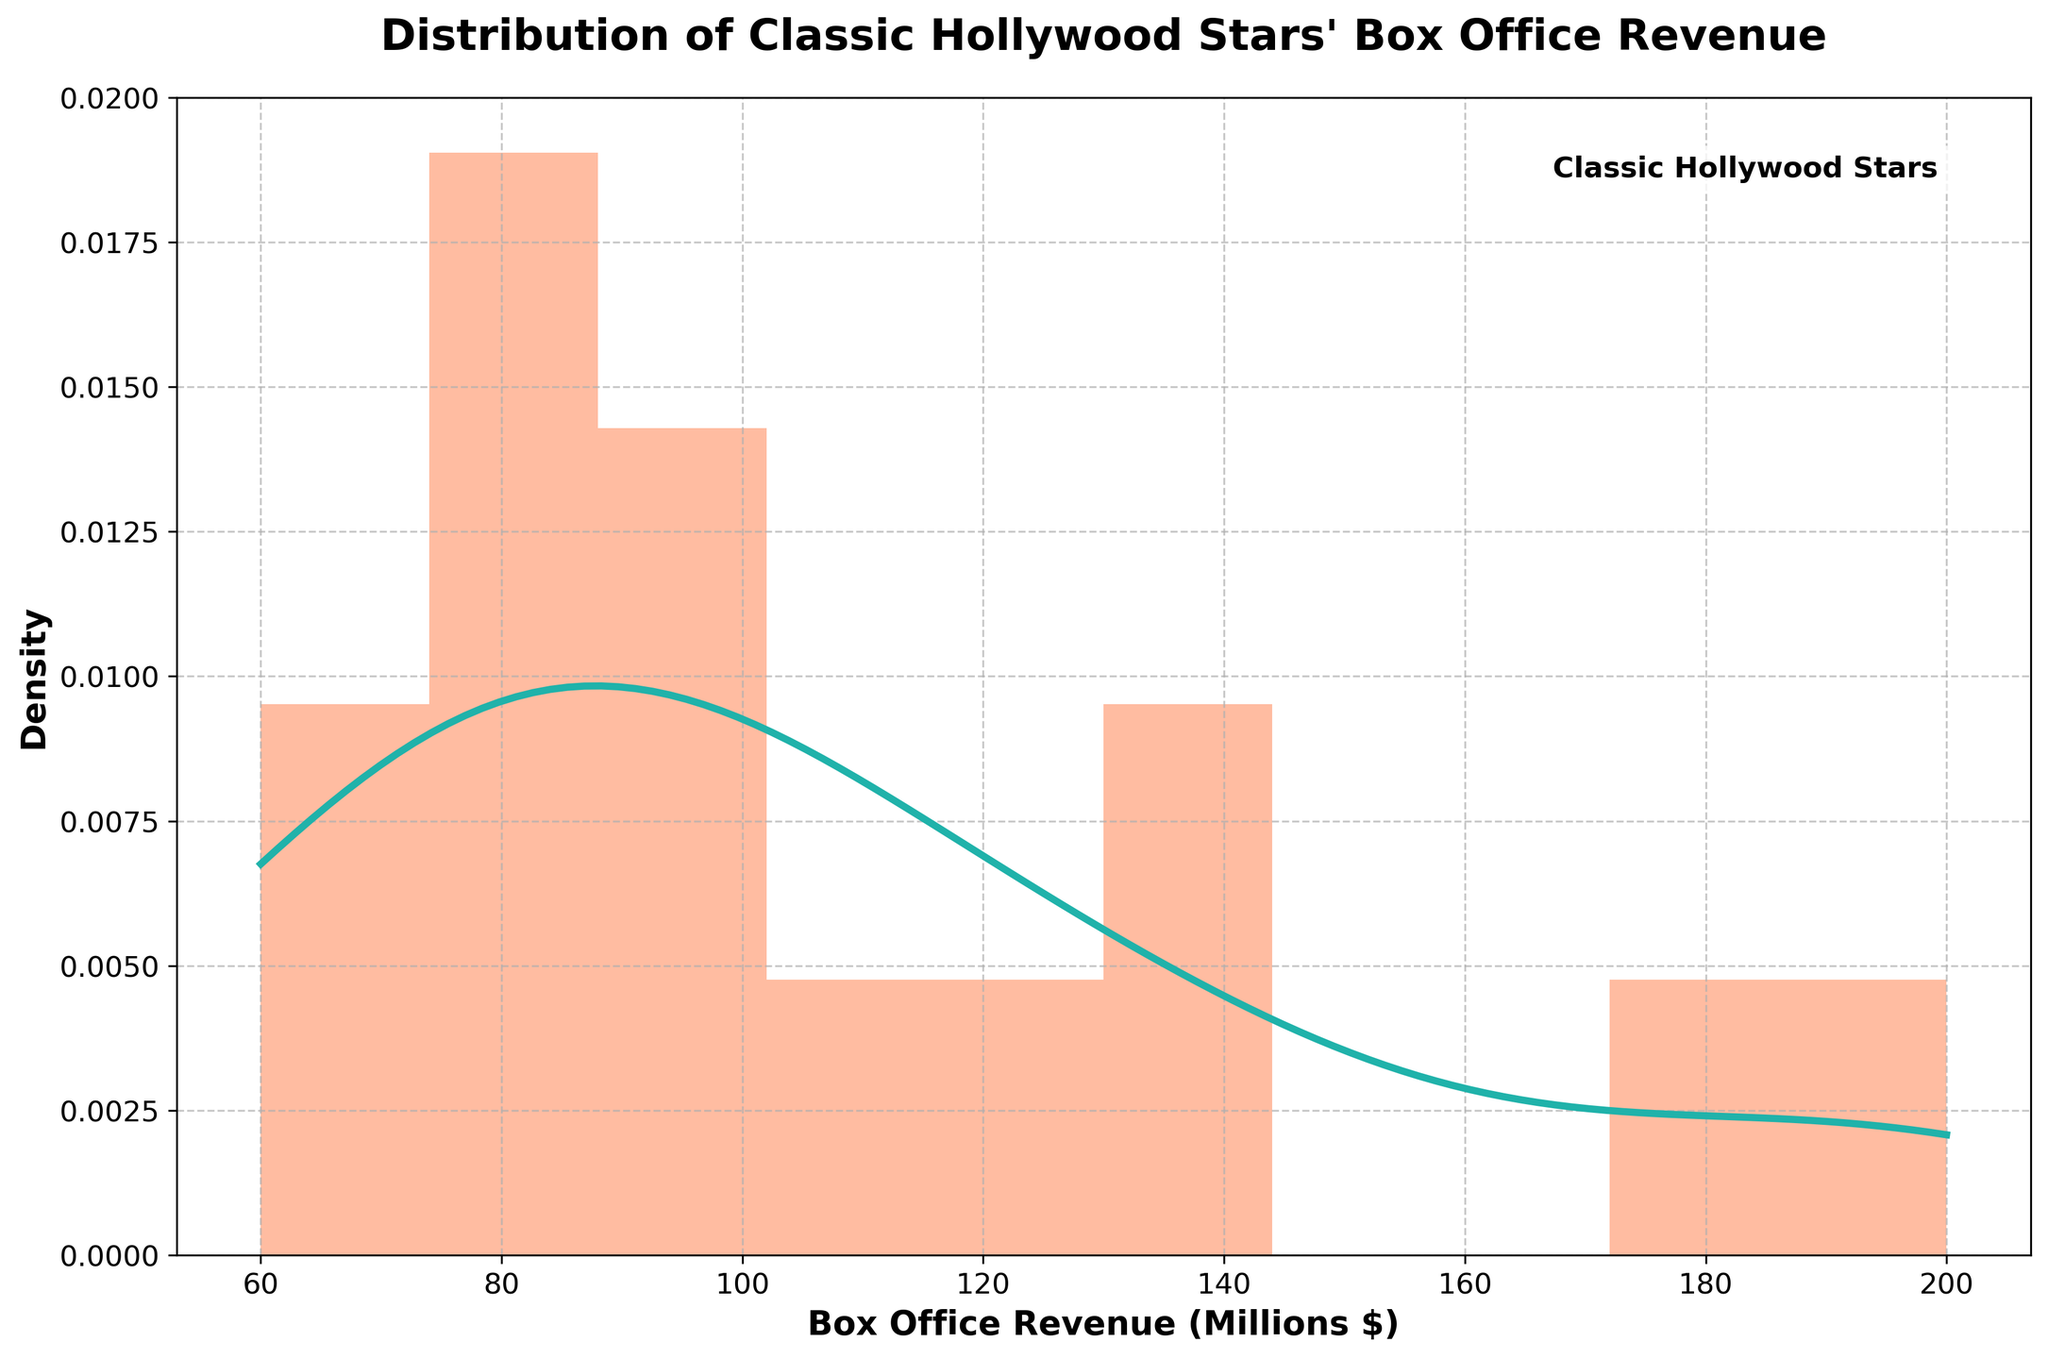What's the title of the figure? The title is typically located at the top of the figure. It gives a summary of what the figure is about, which in this case is 'Distribution of Classic Hollywood Stars' Box Office Revenue'.
Answer: Distribution of Classic Hollywood Stars' Box Office Revenue Which axis shows Box Office Revenue? By looking at the figure, we see that axes are labeled. The x-axis is labeled 'Box Office Revenue (Millions $)', indicating it shows the Box Office Revenue.
Answer: x-axis What does the y-axis represent? The y-axis is labeled 'Density', suggesting that the vertical position of points corresponds to the density estimate of the stars' box office revenue.
Answer: Density How many bars are in the histogram? A histogram typically contains several bars, each representing a range of values. By counting these bars, we can see there are 10 bars in the histogram.
Answer: 10 What can you infer about the range of revenue from the histogram? By examining the x-axis and the coverage of the bars, it is possible to deduce that the revenue ranges from 60 million dollars to 200 million dollars.
Answer: 60 million to 200 million dollars Which color represents the KDE curve? By observing the plot, we can see that the KDE curve is drawn in a different color from the bars of the histogram. The color of the KDE curve is '#20B2AA' or a shade of teal.
Answer: Teal What is the shape of the distribution of box office revenue? Examining the KDE curve and the histogram bars, we can notice that the revenue distribution is slightly skewed to the right, with most data points concentrated on the lower end of the revenue scale.
Answer: Right-skewed Which revenue range has the highest density? Looking at the peak of the KDE curve and the histogram, which represent the highest density areas, we can determine that the range around 80 to 120 million dollars has the highest density.
Answer: 80 to 120 million dollars Are there more stars with revenue above or below 100 million dollars? By comparing the distribution of the bars to the right and to the left of the 100 million dollar mark, it can be inferred that there are more stars with revenue below 100 million dollars.
Answer: Below 100 million dollars 